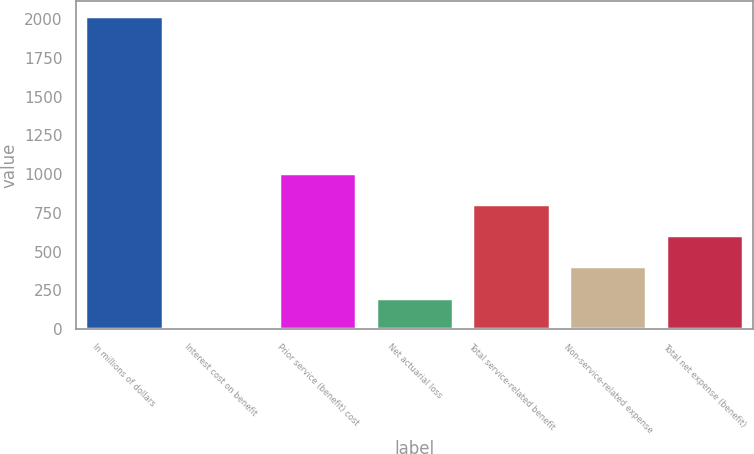<chart> <loc_0><loc_0><loc_500><loc_500><bar_chart><fcel>In millions of dollars<fcel>Interest cost on benefit<fcel>Prior service (benefit) cost<fcel>Net actuarial loss<fcel>Total service-related benefit<fcel>Non-service-related expense<fcel>Total net expense (benefit)<nl><fcel>2018<fcel>2<fcel>1010<fcel>203.6<fcel>808.4<fcel>405.2<fcel>606.8<nl></chart> 